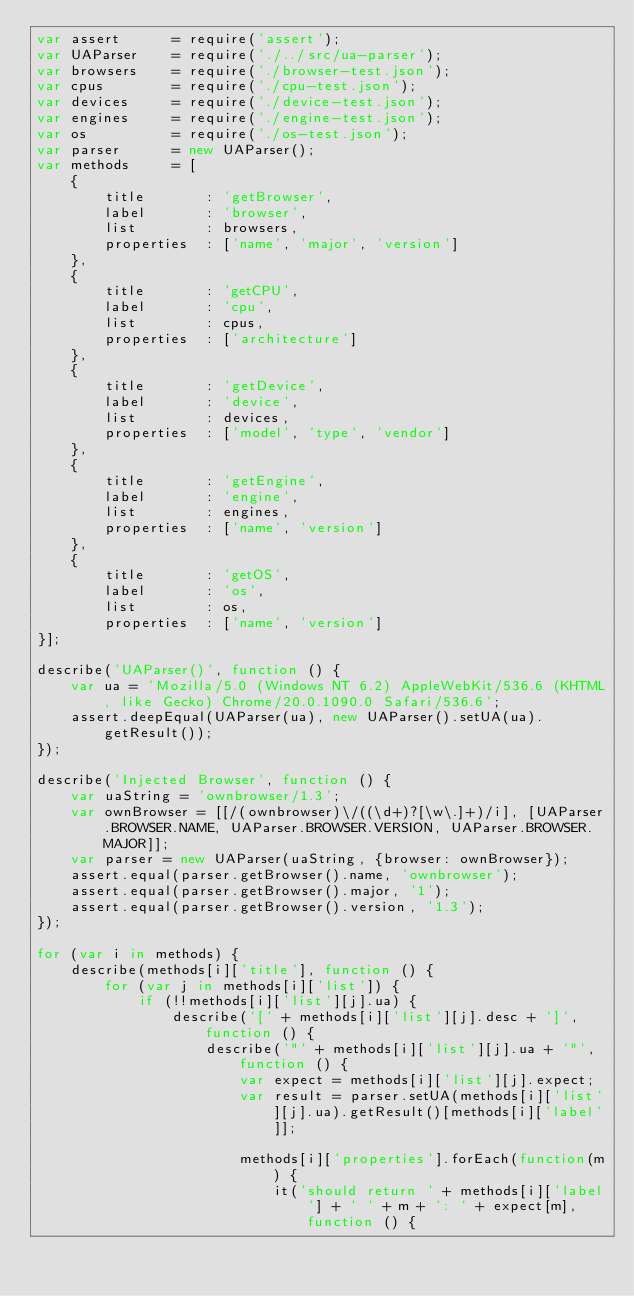<code> <loc_0><loc_0><loc_500><loc_500><_JavaScript_>var assert      = require('assert');
var UAParser    = require('./../src/ua-parser');
var browsers    = require('./browser-test.json');
var cpus        = require('./cpu-test.json');
var devices     = require('./device-test.json');
var engines     = require('./engine-test.json');
var os          = require('./os-test.json');
var parser      = new UAParser();
var methods     = [
    {
        title       : 'getBrowser',
        label       : 'browser',
        list        : browsers,
        properties  : ['name', 'major', 'version']
    },
    {
        title       : 'getCPU',
        label       : 'cpu',
        list        : cpus,
        properties  : ['architecture']
    },
    {
        title       : 'getDevice',
        label       : 'device',
        list        : devices,
        properties  : ['model', 'type', 'vendor']
    },
    {
        title       : 'getEngine',
        label       : 'engine',
        list        : engines,
        properties  : ['name', 'version']
    },
    {
        title       : 'getOS',
        label       : 'os',
        list        : os,
        properties  : ['name', 'version']
}];

describe('UAParser()', function () {
    var ua = 'Mozilla/5.0 (Windows NT 6.2) AppleWebKit/536.6 (KHTML, like Gecko) Chrome/20.0.1090.0 Safari/536.6';
    assert.deepEqual(UAParser(ua), new UAParser().setUA(ua).getResult());
});

describe('Injected Browser', function () {
    var uaString = 'ownbrowser/1.3';
    var ownBrowser = [[/(ownbrowser)\/((\d+)?[\w\.]+)/i], [UAParser.BROWSER.NAME, UAParser.BROWSER.VERSION, UAParser.BROWSER.MAJOR]];
    var parser = new UAParser(uaString, {browser: ownBrowser});
    assert.equal(parser.getBrowser().name, 'ownbrowser');
    assert.equal(parser.getBrowser().major, '1');
    assert.equal(parser.getBrowser().version, '1.3');
});

for (var i in methods) {
    describe(methods[i]['title'], function () {
        for (var j in methods[i]['list']) {
            if (!!methods[i]['list'][j].ua) {
                describe('[' + methods[i]['list'][j].desc + ']', function () {
                    describe('"' + methods[i]['list'][j].ua + '"', function () {
                        var expect = methods[i]['list'][j].expect;
                        var result = parser.setUA(methods[i]['list'][j].ua).getResult()[methods[i]['label']];

                        methods[i]['properties'].forEach(function(m) {
                            it('should return ' + methods[i]['label'] + ' ' + m + ': ' + expect[m], function () {</code> 